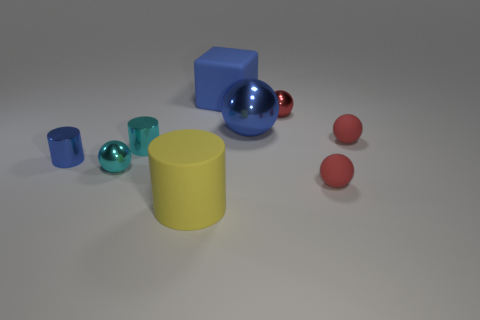What shape is the thing on the left side of the small shiny ball in front of the tiny cyan shiny cylinder that is left of the large shiny ball?
Provide a succinct answer. Cylinder. What size is the red metallic ball?
Make the answer very short. Small. There is another small cylinder that is the same material as the tiny cyan cylinder; what is its color?
Offer a very short reply. Blue. What number of large cubes are the same material as the yellow cylinder?
Your answer should be compact. 1. There is a block; is it the same color as the tiny ball to the left of the small red shiny ball?
Make the answer very short. No. The matte sphere that is to the right of the red thing in front of the cyan cylinder is what color?
Keep it short and to the point. Red. What is the color of the other metallic cylinder that is the same size as the blue metal cylinder?
Provide a short and direct response. Cyan. Is there a cyan metallic thing of the same shape as the large blue shiny object?
Your response must be concise. Yes. What shape is the red metallic thing?
Offer a terse response. Sphere. Is the number of blue cylinders in front of the blue metal ball greater than the number of big blue shiny objects that are behind the matte block?
Offer a very short reply. Yes. 